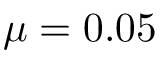Convert formula to latex. <formula><loc_0><loc_0><loc_500><loc_500>\mu = 0 . 0 5</formula> 